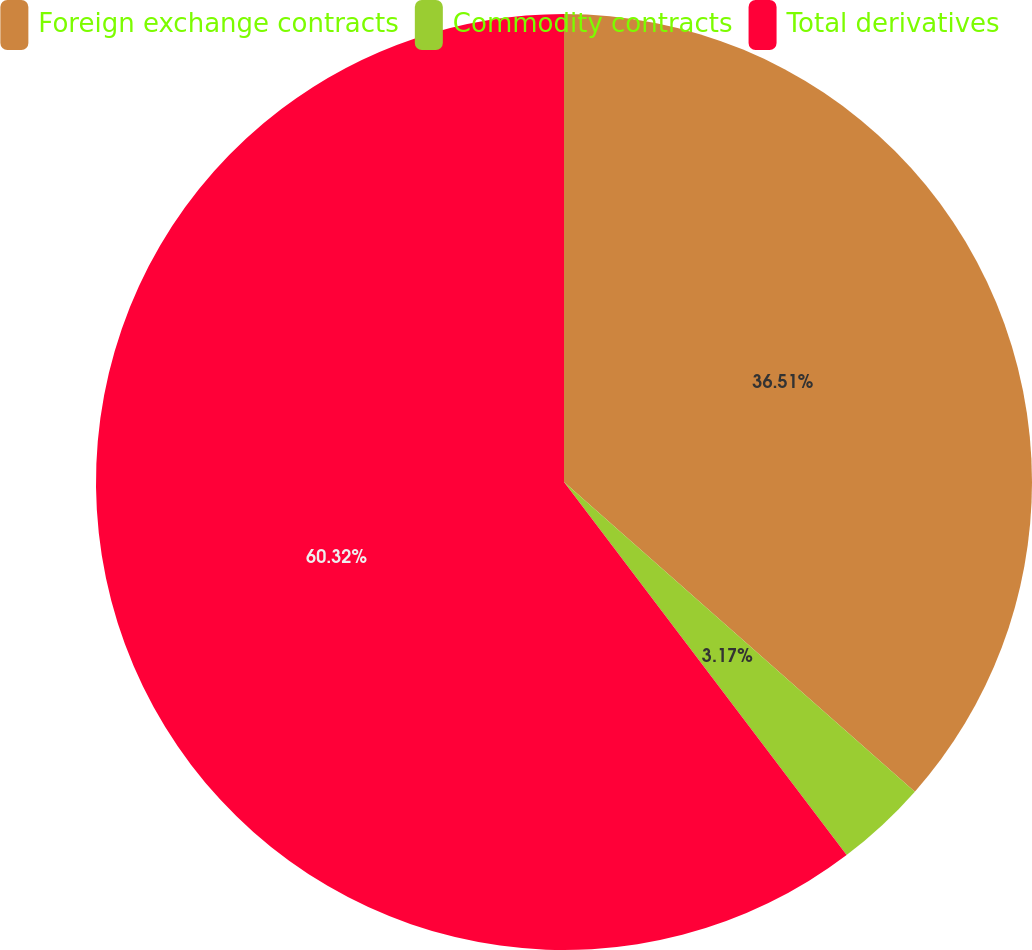<chart> <loc_0><loc_0><loc_500><loc_500><pie_chart><fcel>Foreign exchange contracts<fcel>Commodity contracts<fcel>Total derivatives<nl><fcel>36.51%<fcel>3.17%<fcel>60.32%<nl></chart> 